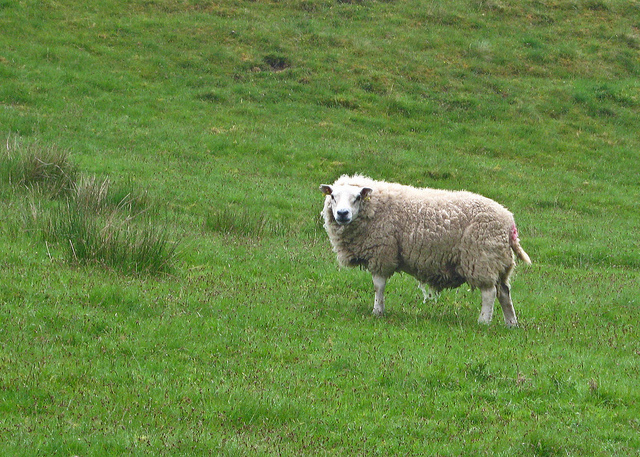<image>What do you think the sheep is thinking? It is unanswerable to know what the sheep is thinking. What do you think the sheep is thinking? I don't know what the sheep is thinking. It can be thinking 'go away', 'eating', 'why are you looking at me', 'run' or 'what are you looking at'. 